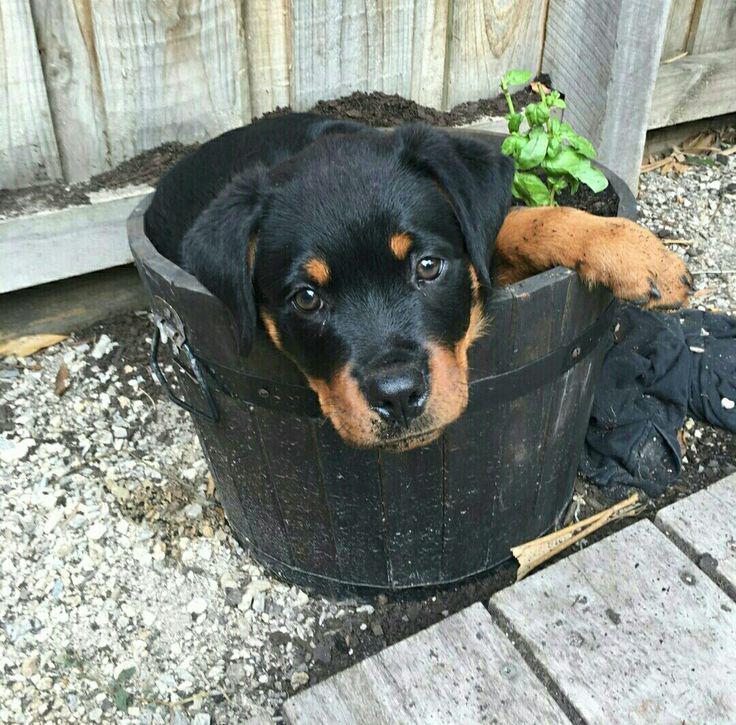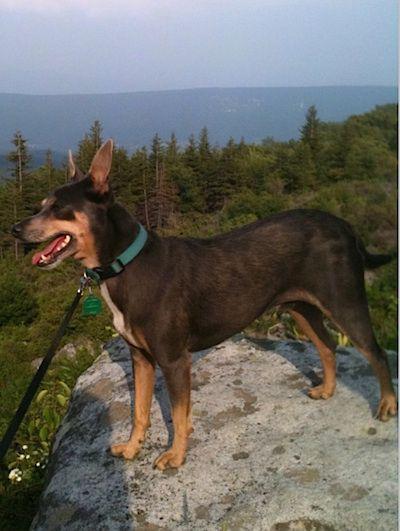The first image is the image on the left, the second image is the image on the right. For the images shown, is this caption "All images include a beagle in an outdoor setting, and at least one image shows multiple beagles behind a prey animal." true? Answer yes or no. No. The first image is the image on the left, the second image is the image on the right. Considering the images on both sides, is "One dog is standing at attention and facing left." valid? Answer yes or no. Yes. 